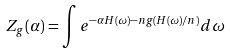<formula> <loc_0><loc_0><loc_500><loc_500>Z _ { g } ( \alpha ) = \int e ^ { - \alpha H ( \omega ) - n g ( H ( \omega ) / n ) } d \omega</formula> 